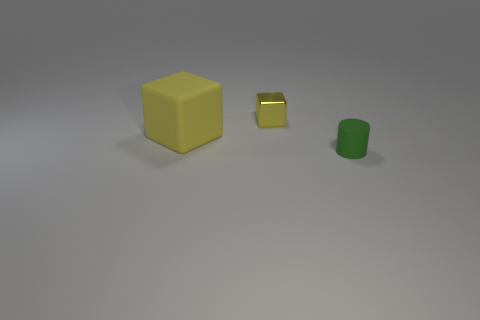What number of other things are there of the same shape as the green thing?
Provide a short and direct response. 0. There is a cube on the left side of the tiny yellow block; what size is it?
Ensure brevity in your answer.  Large. How many brown objects are either cubes or large rubber blocks?
Your answer should be very brief. 0. Is there a yellow shiny object that has the same size as the cylinder?
Your answer should be very brief. Yes. There is a yellow cube that is the same size as the green object; what material is it?
Give a very brief answer. Metal. Is the size of the rubber object that is behind the tiny green rubber thing the same as the yellow object behind the yellow matte thing?
Ensure brevity in your answer.  No. How many objects are either matte cubes or small objects that are to the left of the green object?
Make the answer very short. 2. Is there a small metallic object of the same shape as the large thing?
Ensure brevity in your answer.  Yes. There is a yellow cube that is in front of the tiny object left of the green matte thing; how big is it?
Offer a very short reply. Large. Is the big block the same color as the metallic thing?
Offer a terse response. Yes. 